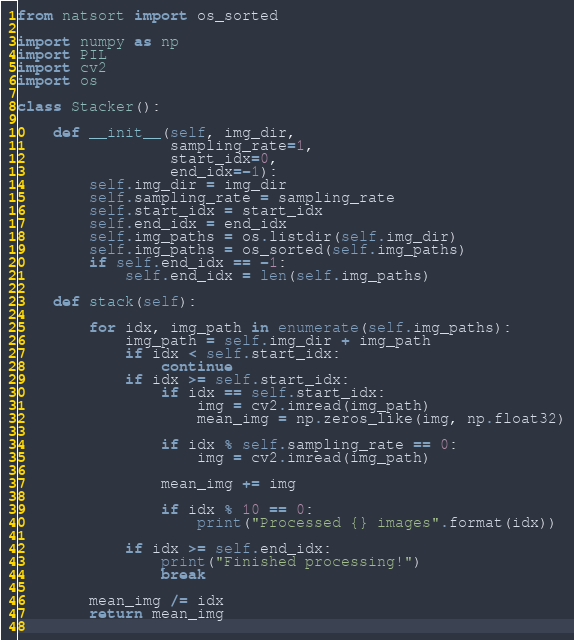Convert code to text. <code><loc_0><loc_0><loc_500><loc_500><_Python_>from natsort import os_sorted

import numpy as np
import PIL
import cv2 
import os

class Stacker():

    def __init__(self, img_dir,
                 sampling_rate=1,
                 start_idx=0,
                 end_idx=-1):
        self.img_dir = img_dir
        self.sampling_rate = sampling_rate
        self.start_idx = start_idx
        self.end_idx = end_idx
        self.img_paths = os.listdir(self.img_dir)
        self.img_paths = os_sorted(self.img_paths)
        if self.end_idx == -1:
            self.end_idx = len(self.img_paths)

    def stack(self):

        for idx, img_path in enumerate(self.img_paths):
            img_path = self.img_dir + img_path
            if idx < self.start_idx:
                continue
            if idx >= self.start_idx:
                if idx == self.start_idx:
                    img = cv2.imread(img_path)
                    mean_img = np.zeros_like(img, np.float32)

                if idx % self.sampling_rate == 0:
                    img = cv2.imread(img_path)
                
                mean_img += img

                if idx % 10 == 0:
                    print("Processed {} images".format(idx))
            
            if idx >= self.end_idx:
                print("Finished processing!")
                break
        
        mean_img /= idx
        return mean_img
                
</code> 